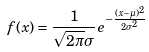<formula> <loc_0><loc_0><loc_500><loc_500>f ( x ) = { \frac { 1 } { { \sqrt { 2 \pi } } \sigma } } e ^ { - { \frac { ( x - \mu ) ^ { 2 } } { 2 \sigma ^ { 2 } } } }</formula> 